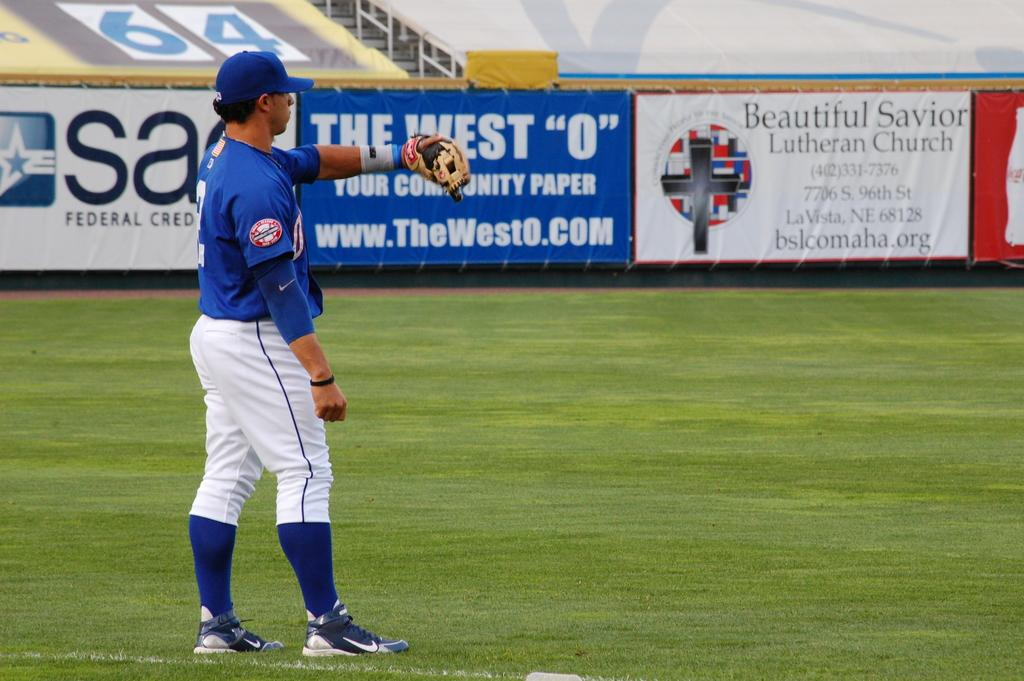<image>
Give a short and clear explanation of the subsequent image. A blue sign at the edge of the ball field says "the west 0" on it. 